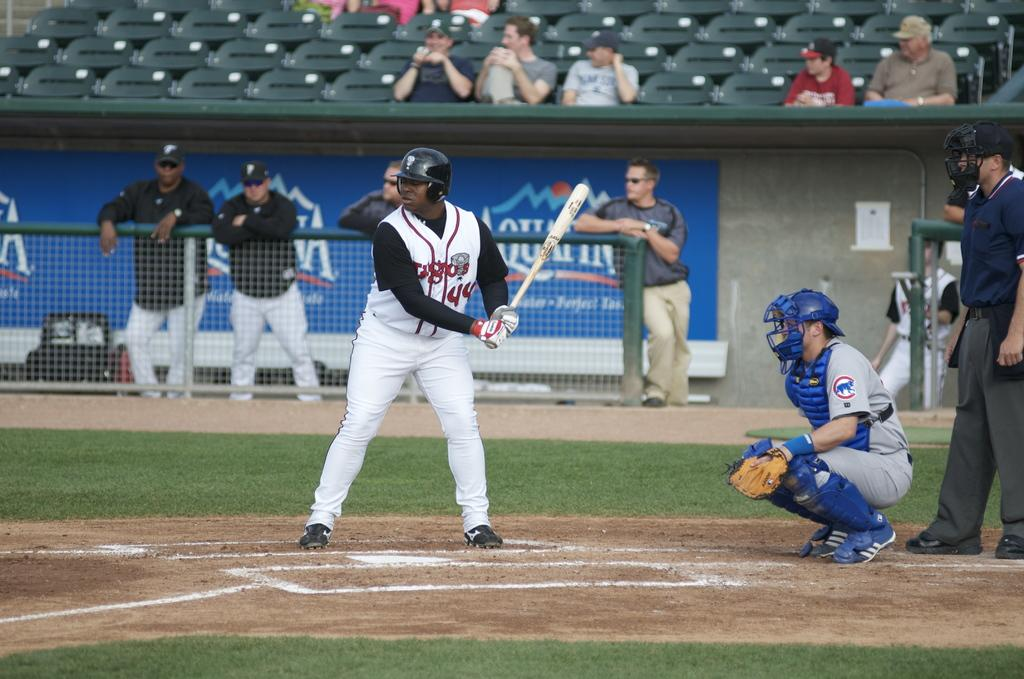<image>
Share a concise interpretation of the image provided. A batter is preparing to bat with an Aquafina ad behind him. 